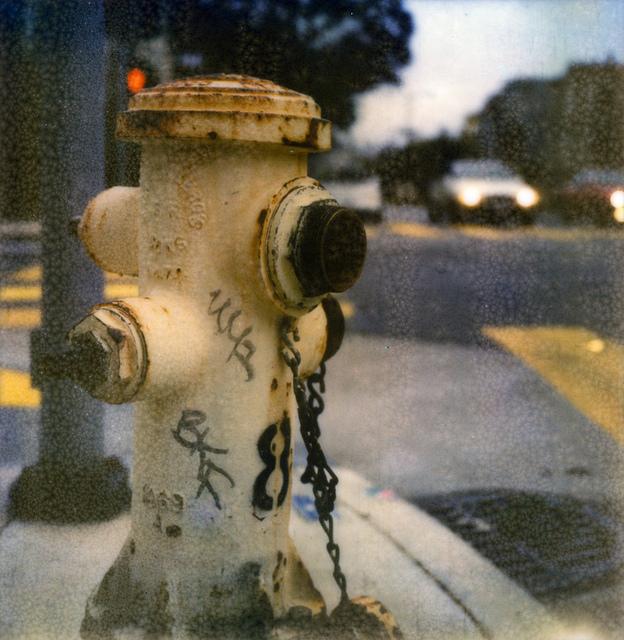Does this seem well maintained?
Be succinct. No. What color is the safety device?
Write a very short answer. White. Is this yellow hydrant regularly inspected and maintained?
Quick response, please. No. Are the car's headlights on?
Give a very brief answer. Yes. Is the hydrant being used?
Answer briefly. No. What color is the hydrant?
Give a very brief answer. Yellow. 